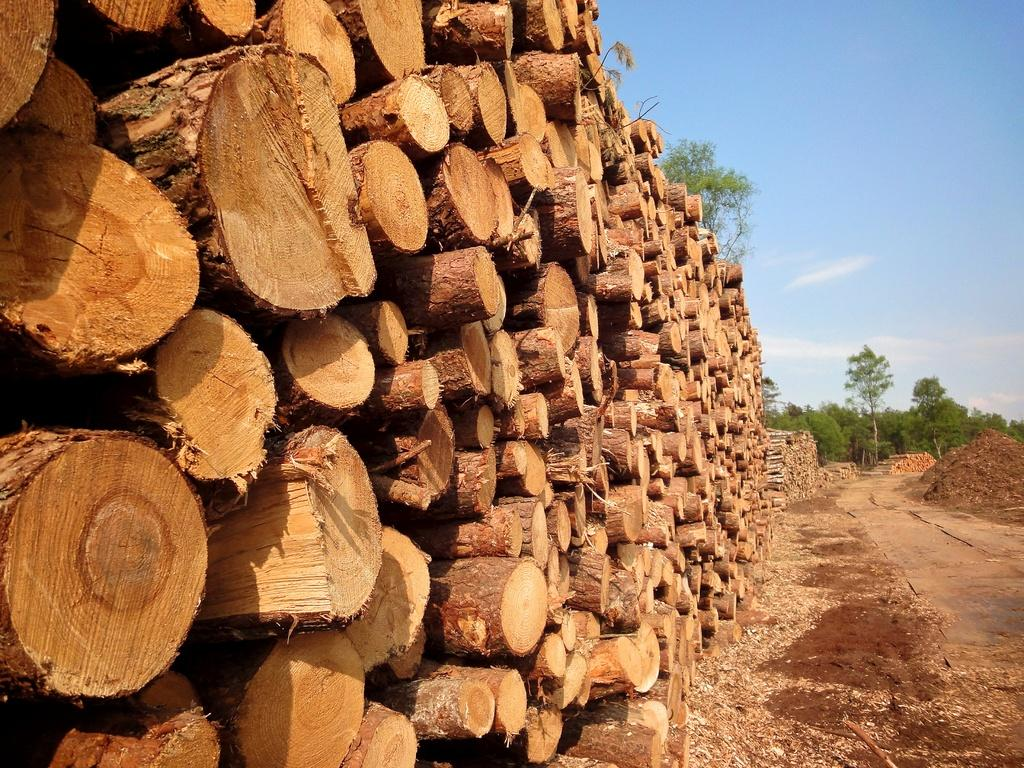What type of material can be seen in the image? There is wood in the image. What type of natural vegetation is present in the image? There are trees in the image. What type of terrain can be seen in the image? There is sand in the image. What is visible in the background of the image? The sky is visible in the background of the image. What can be observed in the sky in the image? Clouds are present in the sky. What type of egg is being used as an invention in the image? There is no egg or invention present in the image. What type of crate is being used to store the wood in the image? There is no crate present in the image; the wood is not being stored in a crate. 